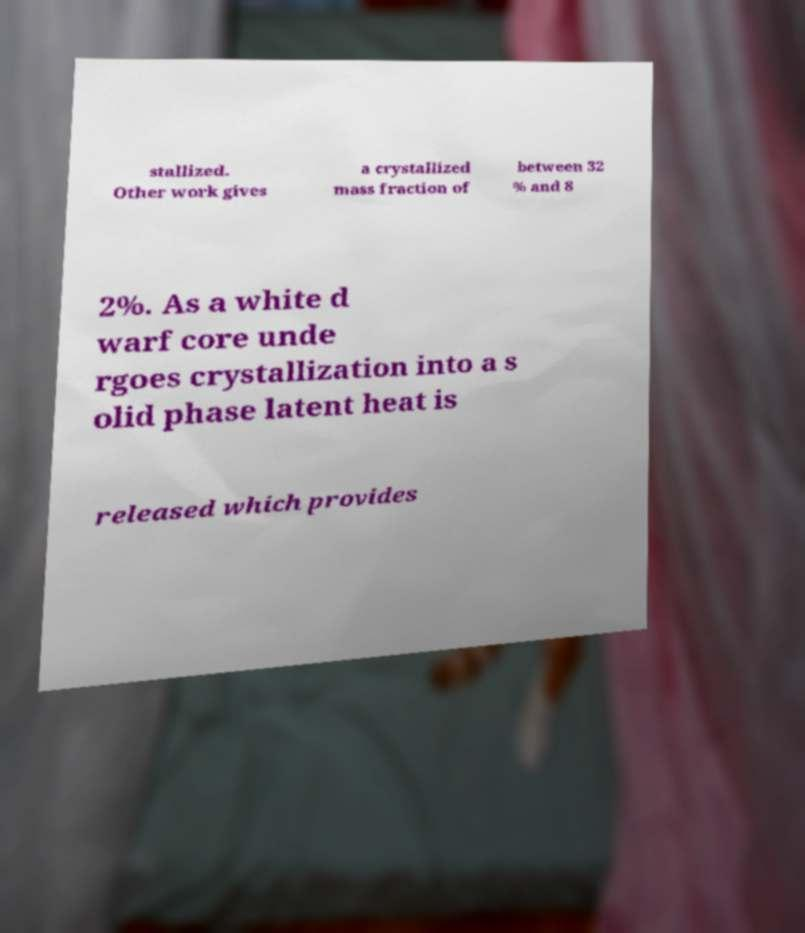Could you assist in decoding the text presented in this image and type it out clearly? stallized. Other work gives a crystallized mass fraction of between 32 % and 8 2%. As a white d warf core unde rgoes crystallization into a s olid phase latent heat is released which provides 